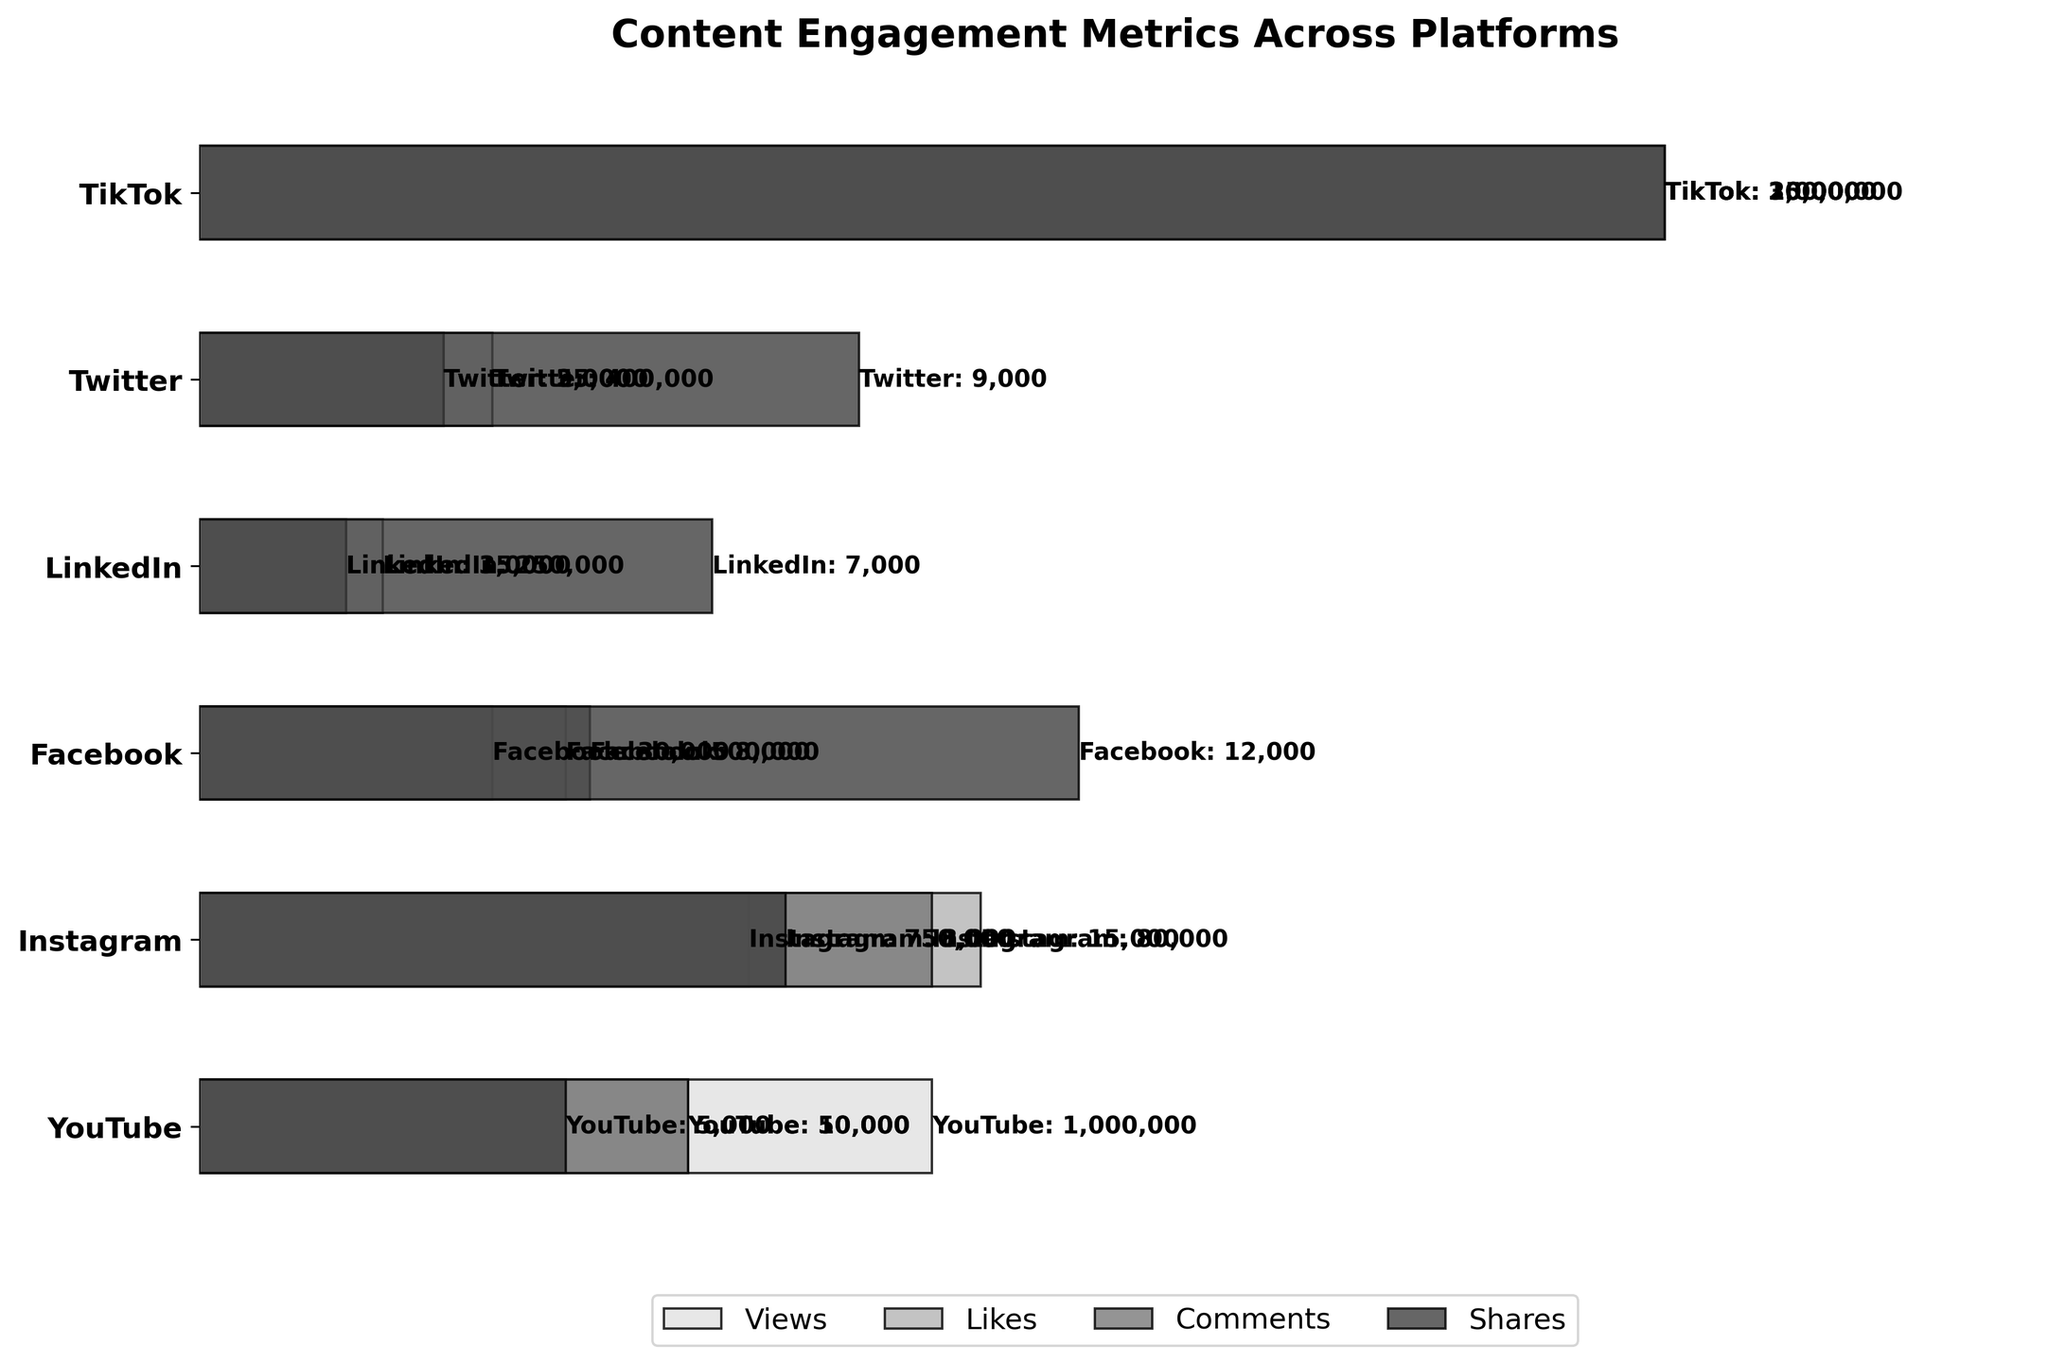How many platforms are represented in the chart? There are six different platforms in the chart: YouTube, Instagram, Facebook, LinkedIn, Twitter, and TikTok. The platforms are listed on the Y-axis.
Answer: 6 Which platform has the highest number of views? The bar for YouTube extends the furthest to the right among the 'Views' bars, indicating that YouTube has the highest number of views at 1,000,000.
Answer: YouTube What is the total number of shares across all platforms? To find the total number of shares, sum the shares from each platform: 5,000 (YouTube) + 8,000 (Instagram) + 12,000 (Facebook) + 7,000 (LinkedIn) + 9,000 (Twitter) + 20,000 (TikTok) = 61,000 shares.
Answer: 61,000 Which platform has the most significant drop-off rate from views to likes? Calculate the drop-off rate from views to likes for each platform:
- YouTube: (1,000,000 - 50,000) / 1,000,000 = 0.95
- Instagram: (750,000 - 80,000) / 750,000 = 0.893
- Facebook: (500,000 - 30,000) / 500,000 = 0.94
- LinkedIn: (250,000 - 15,000) / 250,000 = 0.94
- Twitter: (400,000 - 25,000) / 400,000 = 0.9375
- TikTok: (2,000,000 - 150,000) / 2,000,000 = 0.925
YouTube has the highest drop-off rate from views to likes.
Answer: YouTube How does TikTok's engagement (likes, comments, shares) compare to Twitter's? Compare TikTok's engagement metrics to Twitter's:
- Likes: TikTok (150,000) > Twitter (25,000)
- Comments: TikTok (30,000) > Twitter (5,000)
- Shares: TikTok (20,000) > Twitter (9,000)
TikTok has higher engagement in likes, comments, and shares compared to Twitter.
Answer: TikTok has higher engagement Which platform has the smallest number of comments, and what is that number? The bar for LinkedIn under 'Comments' is the shortest, indicating that LinkedIn has the smallest number of comments at 3,000.
Answer: LinkedIn, 3,000 What is the average number of likes across all platforms? To find the average number of likes, sum the likes from each platform: 50,000 (YouTube) + 80,000 (Instagram) + 30,000 (Facebook) + 15,000 (LinkedIn) + 25,000 (Twitter) + 150,000 (TikTok) = 350,000 likes.
Now, divide by the number of platforms: 350,000 / 6 ≈ 58,333 likes.
Answer: 58,333 Which platform has the highest share-to-comment ratio? Calculate the share-to-comment ratio for each platform:
- YouTube: 5,000 / 10,000 = 0.5
- Instagram: 8,000 / 15,000 = 0.533
- Facebook: 12,000 / 8,000 = 1.5
- LinkedIn: 7,000 / 3,000 = 2.33
- Twitter: 9,000 / 5,000 = 1.8
- TikTok: 20,000 / 30,000 = 0.67
LinkedIn has the highest share-to-comment ratio.
Answer: LinkedIn 